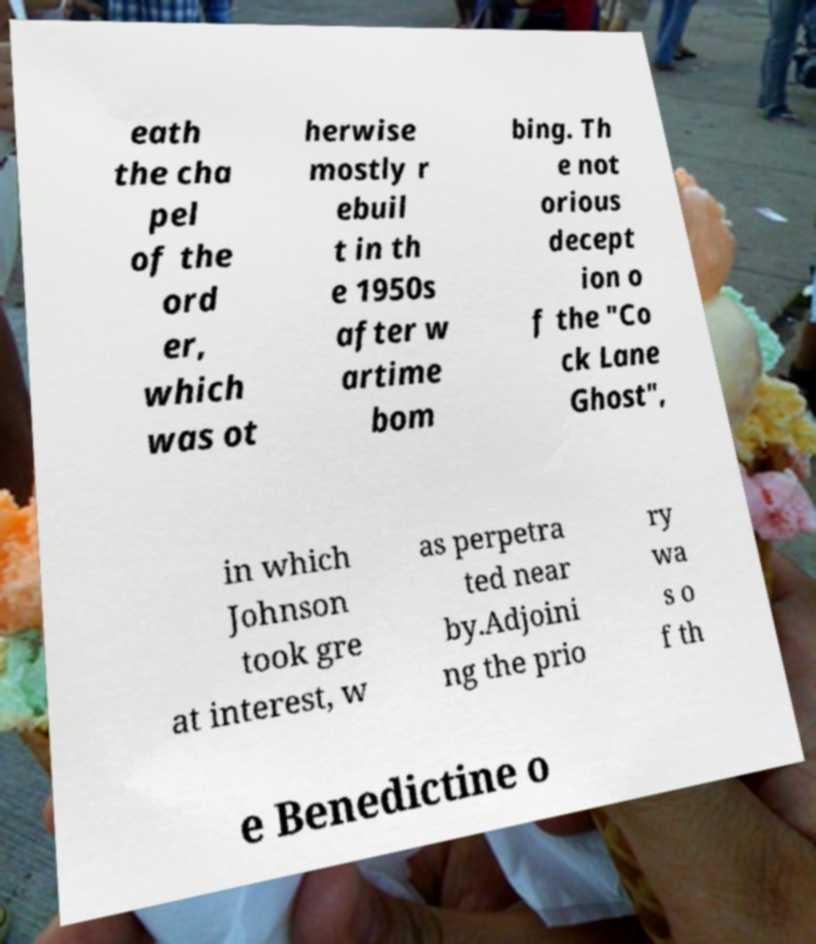What messages or text are displayed in this image? I need them in a readable, typed format. eath the cha pel of the ord er, which was ot herwise mostly r ebuil t in th e 1950s after w artime bom bing. Th e not orious decept ion o f the "Co ck Lane Ghost", in which Johnson took gre at interest, w as perpetra ted near by.Adjoini ng the prio ry wa s o f th e Benedictine o 